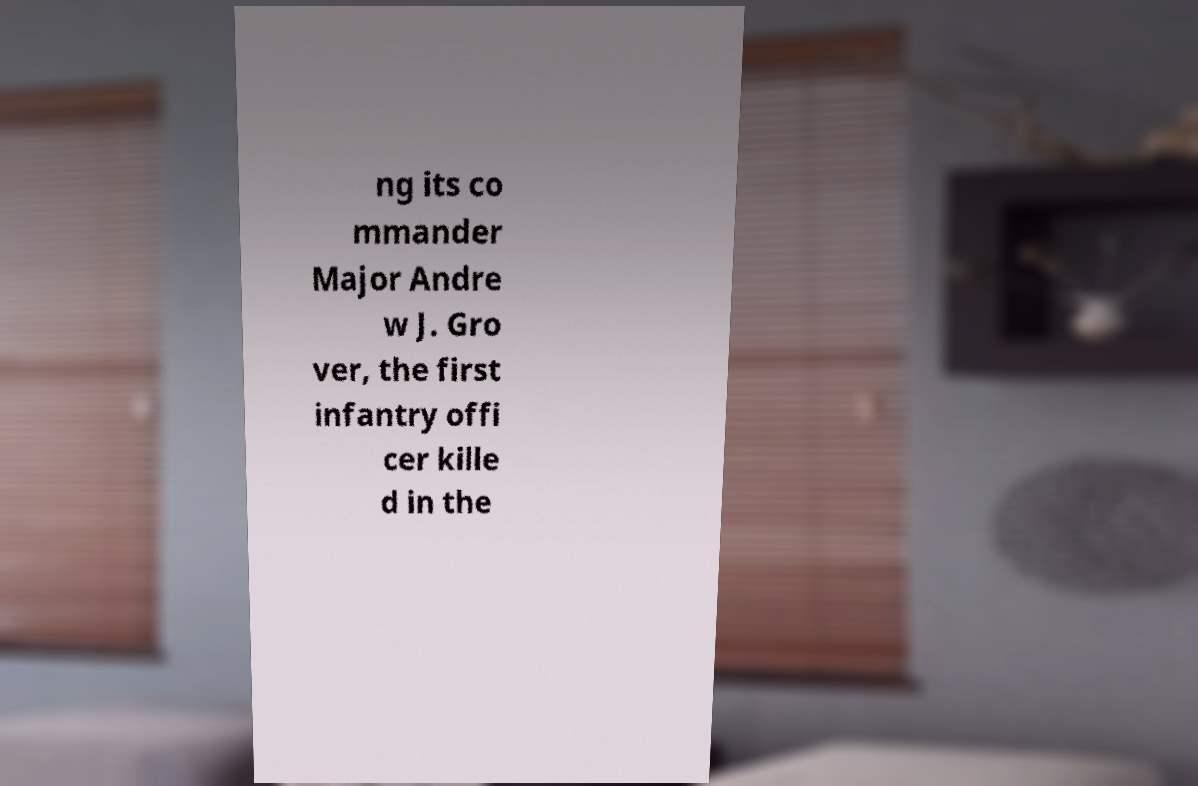Can you accurately transcribe the text from the provided image for me? ng its co mmander Major Andre w J. Gro ver, the first infantry offi cer kille d in the 